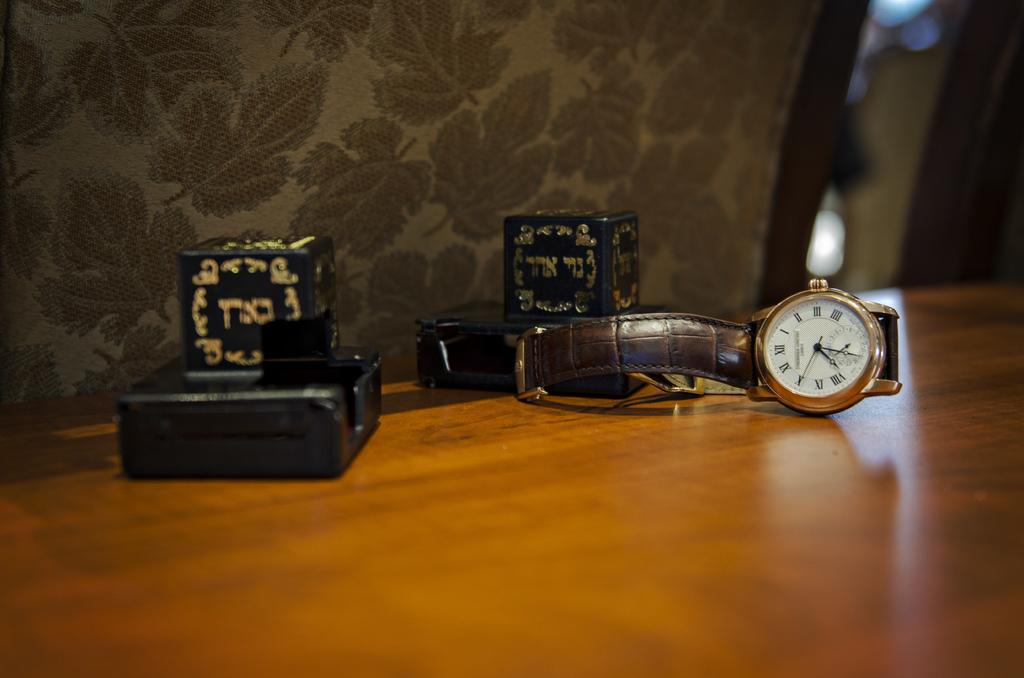<image>
Summarize the visual content of the image. A watch and some boxes sit on a table and the watch says it it 1:00. 